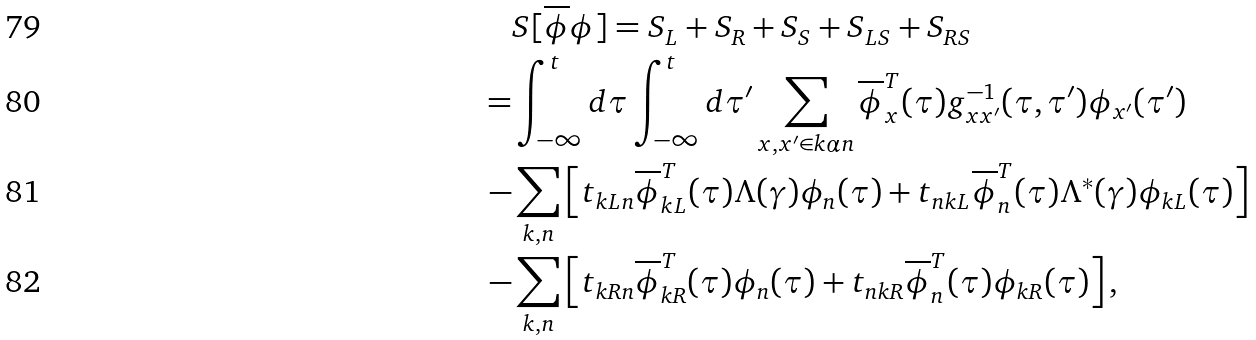<formula> <loc_0><loc_0><loc_500><loc_500>& S [ \overline { \phi } \phi ] = S _ { L } + S _ { R } + S _ { S } + S _ { L S } + S _ { R S } \\ = & \int _ { - \infty } ^ { t } d \tau \int _ { - \infty } ^ { t } d \tau ^ { \prime } \sum _ { x , x ^ { \prime } \in k \alpha n } \overline { \phi } _ { x } ^ { T } ( \tau ) g _ { x x ^ { \prime } } ^ { - 1 } ( \tau , \tau ^ { \prime } ) \phi _ { x ^ { \prime } } ( \tau ^ { \prime } ) \\ - & \sum _ { k , n } \left [ t _ { k L n } \overline { \phi } _ { k L } ^ { T } ( \tau ) \Lambda ( \gamma ) \phi _ { n } ( \tau ) + t _ { n k L } \overline { \phi } _ { n } ^ { T } ( \tau ) \Lambda ^ { * } ( \gamma ) \phi _ { k L } ( \tau ) \right ] \\ - & \sum _ { k , n } \left [ t _ { k R n } \overline { \phi } _ { k R } ^ { T } ( \tau ) \phi _ { n } ( \tau ) + t _ { n k R } \overline { \phi } _ { n } ^ { T } ( \tau ) \phi _ { k R } ( \tau ) \right ] ,</formula> 